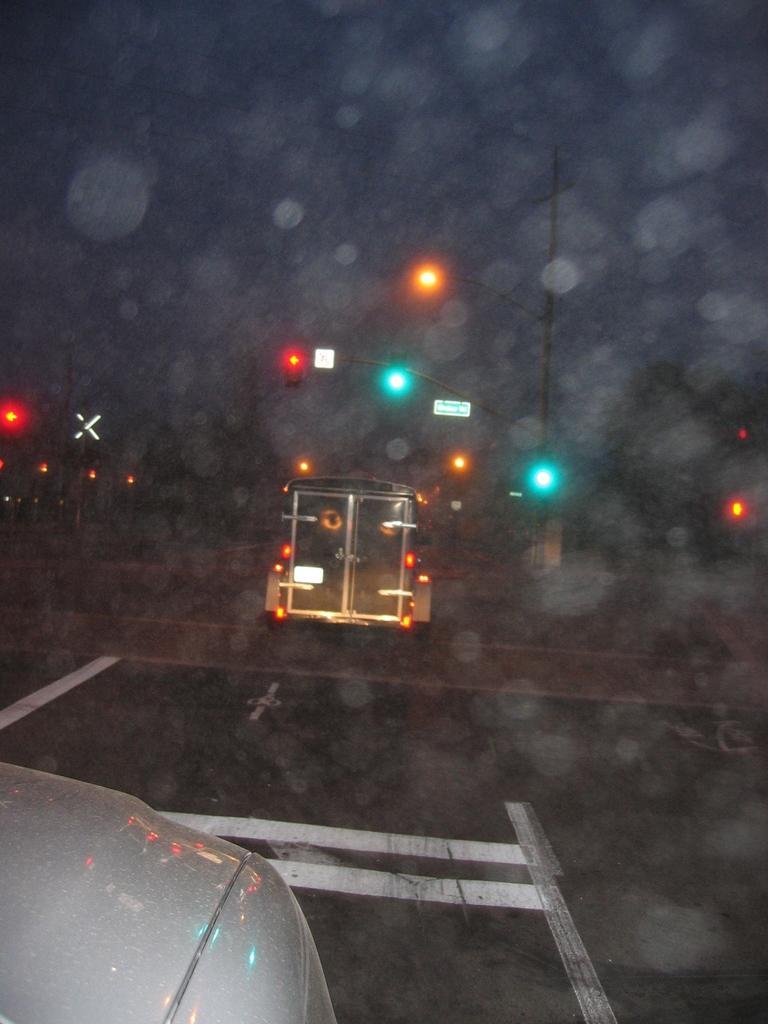In one or two sentences, can you explain what this image depicts? In this picture there is a white vehicle in the left corner and there is another vehicle and few traffic lights in front of it. 